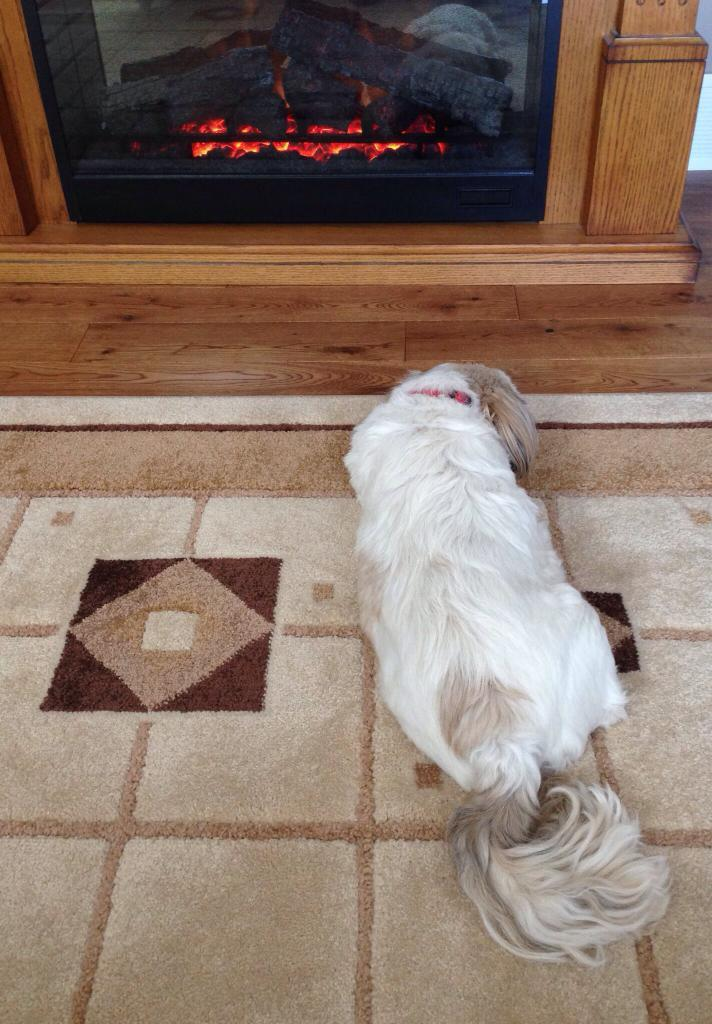What type of animal is in the image? There is a white color dog in the image. What surface is the dog on? The dog is on a carpet. What is the color of the floor visible in the image? The floor is brown in color. What grade does the dog receive for its performance in the image? There is no performance or grade associated with the dog in the image; it is simply a dog on a carpet. 